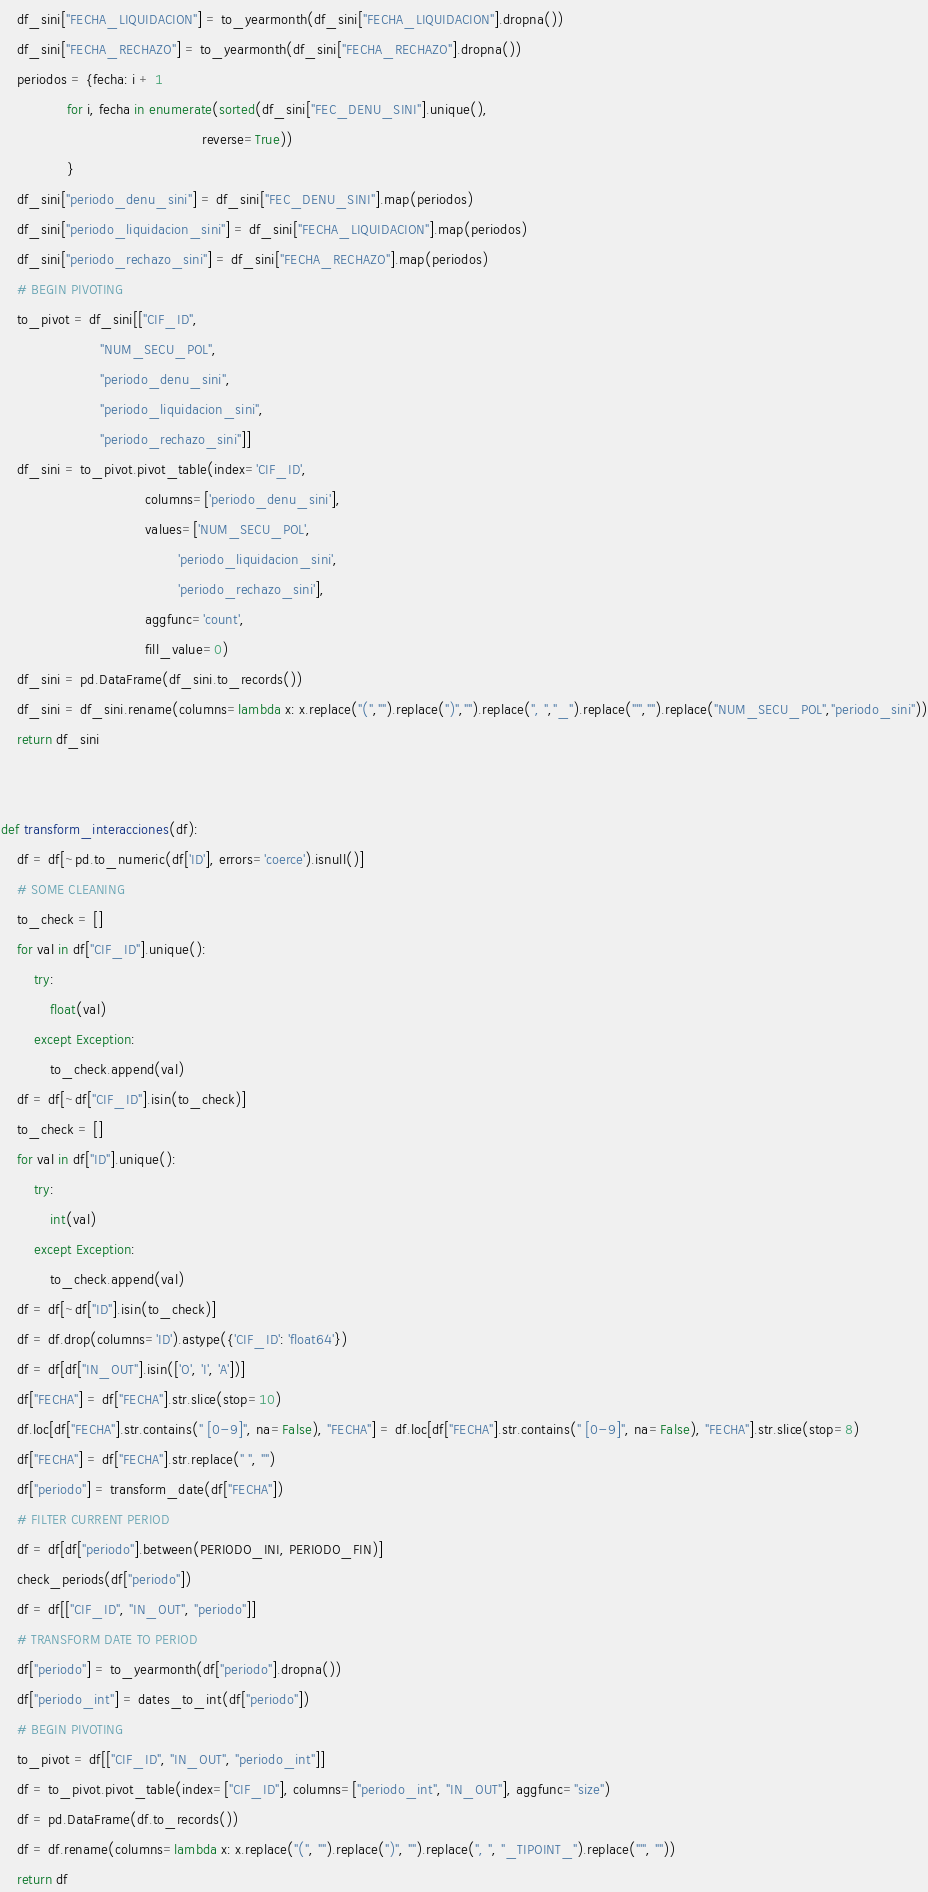<code> <loc_0><loc_0><loc_500><loc_500><_Python_>    df_sini["FECHA_LIQUIDACION"] = to_yearmonth(df_sini["FECHA_LIQUIDACION"].dropna())
    df_sini["FECHA_RECHAZO"] = to_yearmonth(df_sini["FECHA_RECHAZO"].dropna())
    periodos = {fecha: i + 1
                for i, fecha in enumerate(sorted(df_sini["FEC_DENU_SINI"].unique(),
                                                 reverse=True))
                }
    df_sini["periodo_denu_sini"] = df_sini["FEC_DENU_SINI"].map(periodos)
    df_sini["periodo_liquidacion_sini"] = df_sini["FECHA_LIQUIDACION"].map(periodos)
    df_sini["periodo_rechazo_sini"] = df_sini["FECHA_RECHAZO"].map(periodos)
    # BEGIN PIVOTING
    to_pivot = df_sini[["CIF_ID",
                        "NUM_SECU_POL",
                        "periodo_denu_sini",
                        "periodo_liquidacion_sini",
                        "periodo_rechazo_sini"]]
    df_sini = to_pivot.pivot_table(index='CIF_ID',
                                   columns=['periodo_denu_sini'],
                                   values=['NUM_SECU_POL',
                                           'periodo_liquidacion_sini',
                                           'periodo_rechazo_sini'],
                                   aggfunc='count',
                                   fill_value=0)
    df_sini = pd.DataFrame(df_sini.to_records())
    df_sini = df_sini.rename(columns=lambda x: x.replace("(","").replace(")","").replace(", ","_").replace("'","").replace("NUM_SECU_POL","periodo_sini"))
    return df_sini


def transform_interacciones(df):
    df = df[~pd.to_numeric(df['ID'], errors='coerce').isnull()]
    # SOME CLEANING
    to_check = []
    for val in df["CIF_ID"].unique():
        try:
            float(val)
        except Exception:
            to_check.append(val)
    df = df[~df["CIF_ID"].isin(to_check)]
    to_check = []
    for val in df["ID"].unique():
        try:
            int(val)
        except Exception:
            to_check.append(val)
    df = df[~df["ID"].isin(to_check)]
    df = df.drop(columns='ID').astype({'CIF_ID': 'float64'})
    df = df[df["IN_OUT"].isin(['O', 'I', 'A'])]
    df["FECHA"] = df["FECHA"].str.slice(stop=10)
    df.loc[df["FECHA"].str.contains(" [0-9]", na=False), "FECHA"] = df.loc[df["FECHA"].str.contains(" [0-9]", na=False), "FECHA"].str.slice(stop=8) 
    df["FECHA"] = df["FECHA"].str.replace(" ", "")
    df["periodo"] = transform_date(df["FECHA"])
    # FILTER CURRENT PERIOD
    df = df[df["periodo"].between(PERIODO_INI, PERIODO_FIN)]
    check_periods(df["periodo"])
    df = df[["CIF_ID", "IN_OUT", "periodo"]]
    # TRANSFORM DATE TO PERIOD
    df["periodo"] = to_yearmonth(df["periodo"].dropna())
    df["periodo_int"] = dates_to_int(df["periodo"])
    # BEGIN PIVOTING
    to_pivot = df[["CIF_ID", "IN_OUT", "periodo_int"]]
    df = to_pivot.pivot_table(index=["CIF_ID"], columns=["periodo_int", "IN_OUT"], aggfunc="size")
    df = pd.DataFrame(df.to_records())
    df = df.rename(columns=lambda x: x.replace("(", "").replace(")", "").replace(", ", "_TIPOINT_").replace("'", "")) 
    return df
</code> 